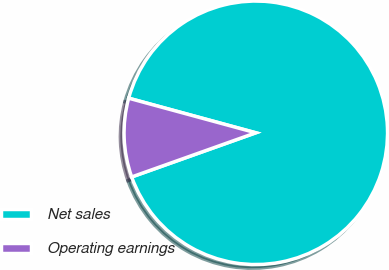<chart> <loc_0><loc_0><loc_500><loc_500><pie_chart><fcel>Net sales<fcel>Operating earnings<nl><fcel>90.33%<fcel>9.67%<nl></chart> 